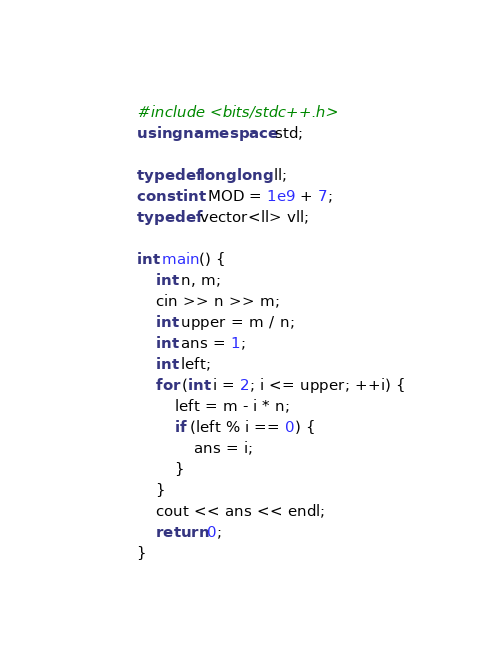<code> <loc_0><loc_0><loc_500><loc_500><_C++_>#include <bits/stdc++.h>
using namespace std;

typedef long long ll;
const int MOD = 1e9 + 7;
typedef vector<ll> vll;

int main() {
    int n, m;
    cin >> n >> m;
    int upper = m / n;
    int ans = 1;
    int left;
    for (int i = 2; i <= upper; ++i) {
        left = m - i * n;
        if (left % i == 0) {
            ans = i;
        }
    }
    cout << ans << endl;
    return 0;
}</code> 